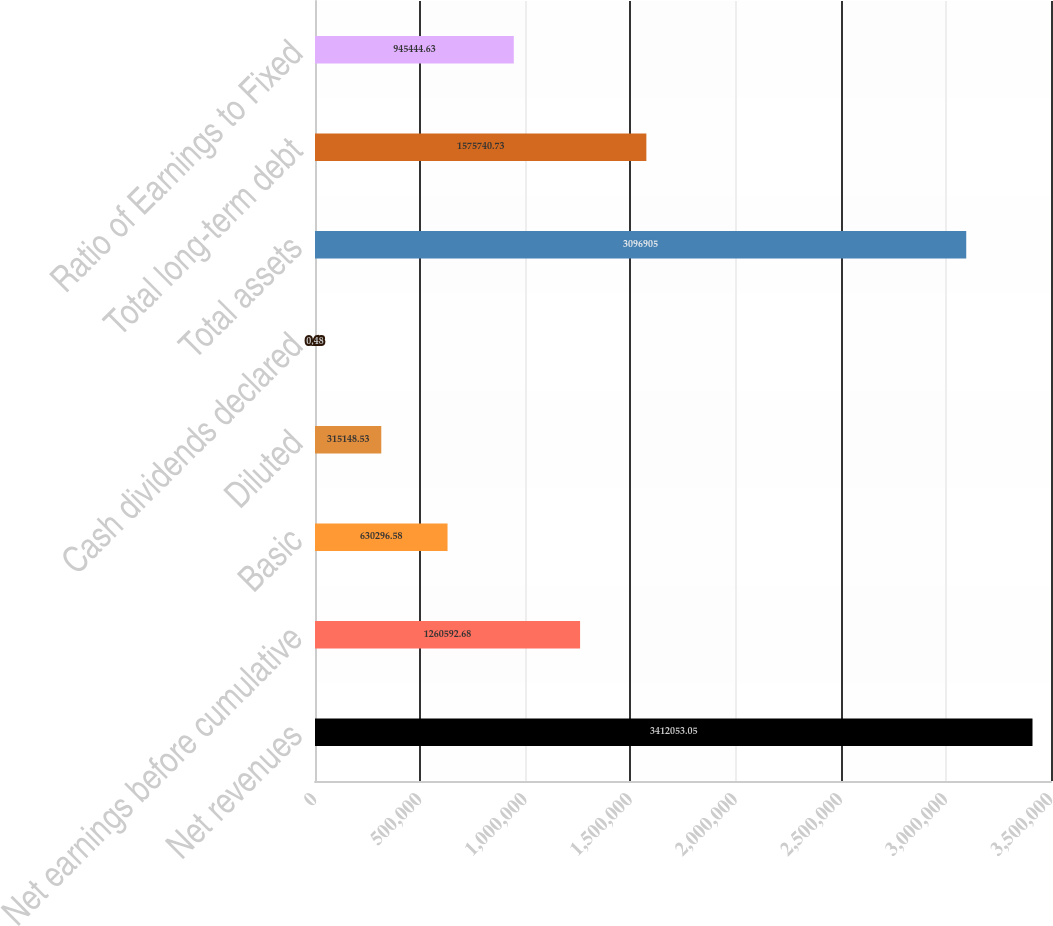<chart> <loc_0><loc_0><loc_500><loc_500><bar_chart><fcel>Net revenues<fcel>Net earnings before cumulative<fcel>Basic<fcel>Diluted<fcel>Cash dividends declared<fcel>Total assets<fcel>Total long-term debt<fcel>Ratio of Earnings to Fixed<nl><fcel>3.41205e+06<fcel>1.26059e+06<fcel>630297<fcel>315149<fcel>0.48<fcel>3.0969e+06<fcel>1.57574e+06<fcel>945445<nl></chart> 